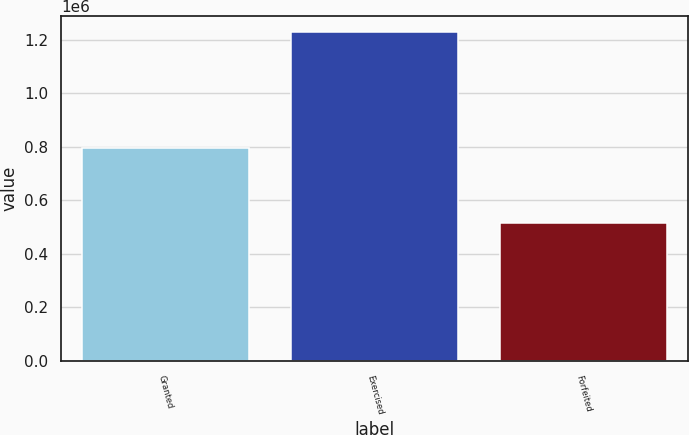Convert chart. <chart><loc_0><loc_0><loc_500><loc_500><bar_chart><fcel>Granted<fcel>Exercised<fcel>Forfeited<nl><fcel>795000<fcel>1.22935e+06<fcel>513954<nl></chart> 